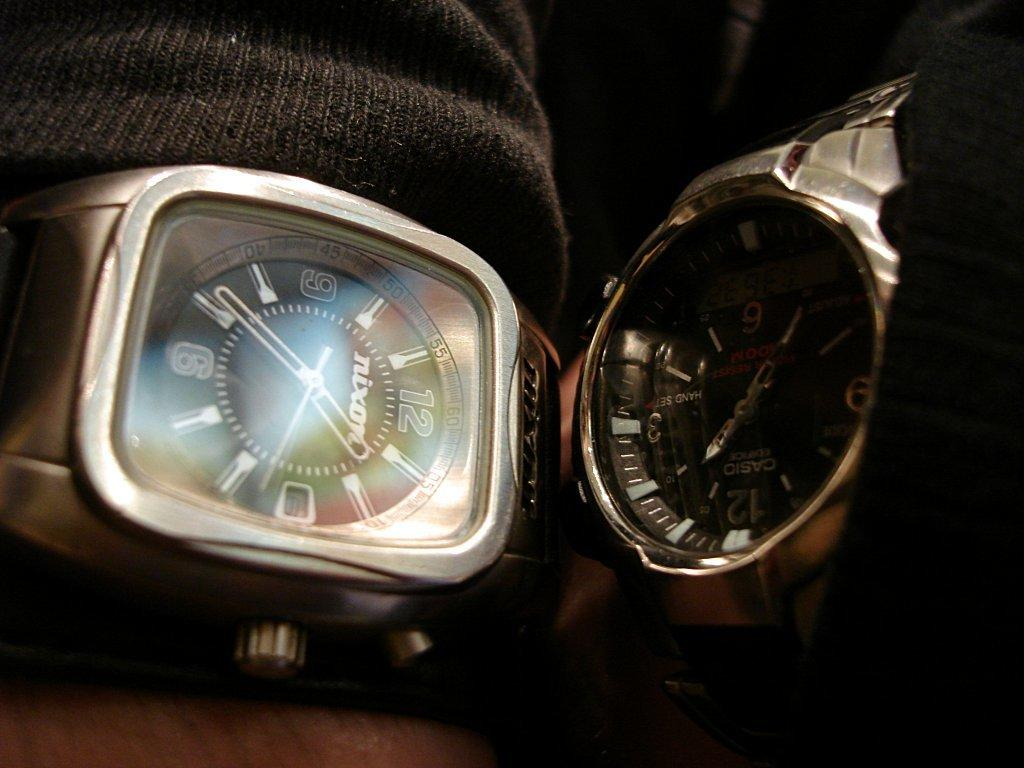<image>
Offer a succinct explanation of the picture presented. A Casio and a Nixon watch are being displayed next to each other. 